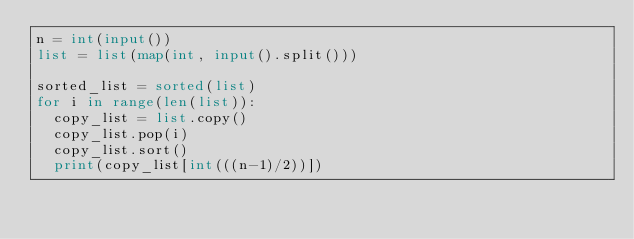<code> <loc_0><loc_0><loc_500><loc_500><_Python_>n = int(input())
list = list(map(int, input().split()))

sorted_list = sorted(list)
for i in range(len(list)):
  copy_list = list.copy()
  copy_list.pop(i)
  copy_list.sort()
  print(copy_list[int(((n-1)/2))])</code> 